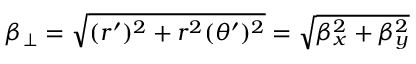<formula> <loc_0><loc_0><loc_500><loc_500>\beta _ { \perp } = \sqrt { ( r ^ { \prime } ) ^ { 2 } + r ^ { 2 } ( \theta ^ { \prime } ) ^ { 2 } } = \sqrt { \beta _ { x } ^ { 2 } + \beta _ { y } ^ { 2 } }</formula> 